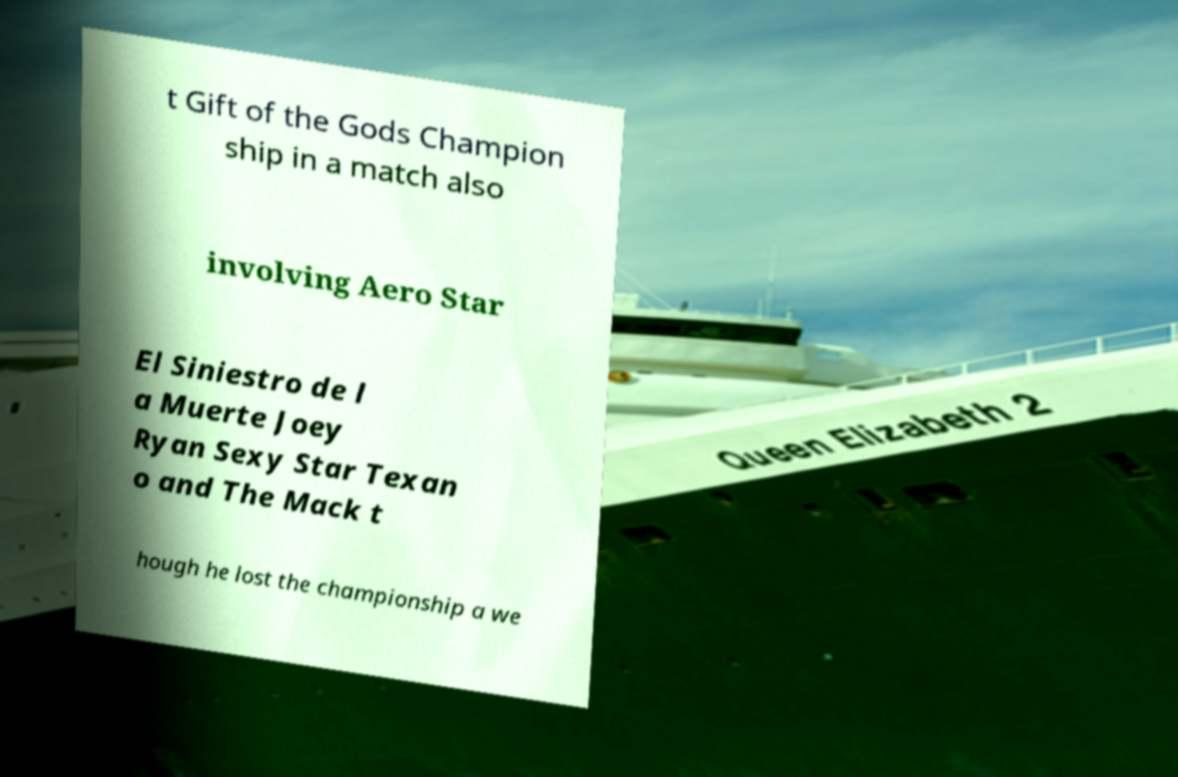Could you extract and type out the text from this image? t Gift of the Gods Champion ship in a match also involving Aero Star El Siniestro de l a Muerte Joey Ryan Sexy Star Texan o and The Mack t hough he lost the championship a we 